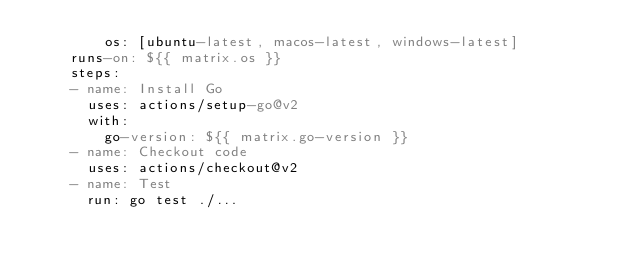Convert code to text. <code><loc_0><loc_0><loc_500><loc_500><_YAML_>        os: [ubuntu-latest, macos-latest, windows-latest]
    runs-on: ${{ matrix.os }}
    steps:
    - name: Install Go
      uses: actions/setup-go@v2
      with:
        go-version: ${{ matrix.go-version }}
    - name: Checkout code
      uses: actions/checkout@v2
    - name: Test
      run: go test ./...</code> 